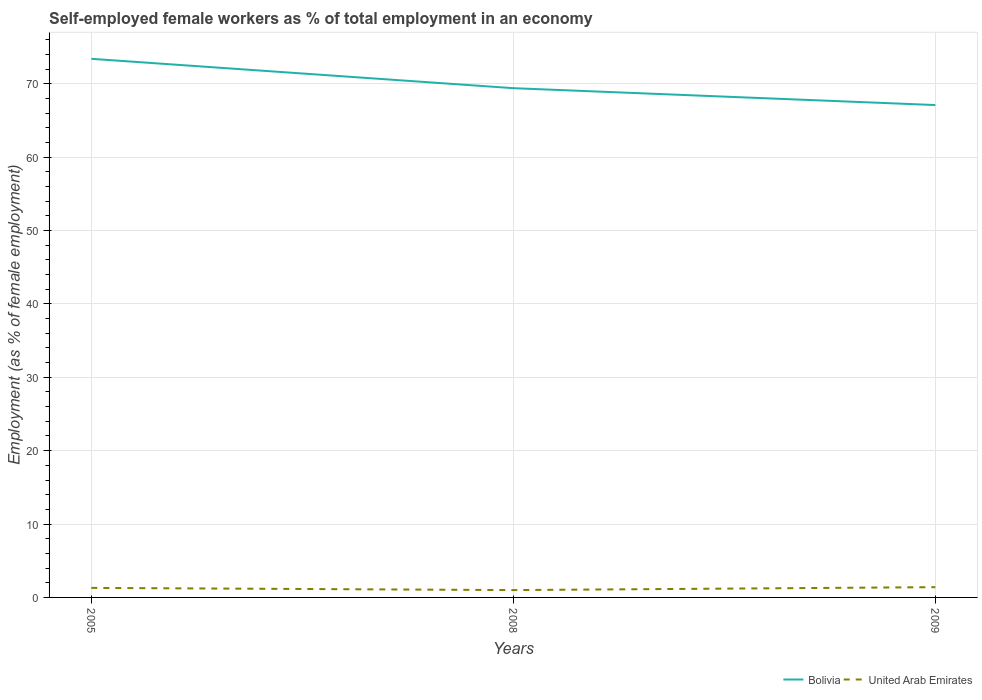Is the number of lines equal to the number of legend labels?
Offer a very short reply. Yes. Across all years, what is the maximum percentage of self-employed female workers in United Arab Emirates?
Offer a terse response. 1. In which year was the percentage of self-employed female workers in Bolivia maximum?
Your response must be concise. 2009. What is the total percentage of self-employed female workers in United Arab Emirates in the graph?
Keep it short and to the point. -0.4. What is the difference between the highest and the second highest percentage of self-employed female workers in United Arab Emirates?
Make the answer very short. 0.4. What is the difference between the highest and the lowest percentage of self-employed female workers in United Arab Emirates?
Offer a terse response. 2. How many years are there in the graph?
Offer a very short reply. 3. What is the difference between two consecutive major ticks on the Y-axis?
Make the answer very short. 10. Does the graph contain any zero values?
Offer a terse response. No. Does the graph contain grids?
Offer a very short reply. Yes. Where does the legend appear in the graph?
Your answer should be compact. Bottom right. How many legend labels are there?
Provide a succinct answer. 2. How are the legend labels stacked?
Your answer should be compact. Horizontal. What is the title of the graph?
Keep it short and to the point. Self-employed female workers as % of total employment in an economy. Does "Poland" appear as one of the legend labels in the graph?
Provide a succinct answer. No. What is the label or title of the Y-axis?
Your response must be concise. Employment (as % of female employment). What is the Employment (as % of female employment) in Bolivia in 2005?
Offer a terse response. 73.4. What is the Employment (as % of female employment) of United Arab Emirates in 2005?
Your answer should be compact. 1.3. What is the Employment (as % of female employment) of Bolivia in 2008?
Offer a very short reply. 69.4. What is the Employment (as % of female employment) of Bolivia in 2009?
Keep it short and to the point. 67.1. What is the Employment (as % of female employment) of United Arab Emirates in 2009?
Offer a terse response. 1.4. Across all years, what is the maximum Employment (as % of female employment) of Bolivia?
Keep it short and to the point. 73.4. Across all years, what is the maximum Employment (as % of female employment) in United Arab Emirates?
Your response must be concise. 1.4. Across all years, what is the minimum Employment (as % of female employment) of Bolivia?
Ensure brevity in your answer.  67.1. Across all years, what is the minimum Employment (as % of female employment) in United Arab Emirates?
Your response must be concise. 1. What is the total Employment (as % of female employment) in Bolivia in the graph?
Your answer should be very brief. 209.9. What is the difference between the Employment (as % of female employment) of Bolivia in 2005 and that in 2008?
Your answer should be compact. 4. What is the difference between the Employment (as % of female employment) in United Arab Emirates in 2005 and that in 2008?
Make the answer very short. 0.3. What is the difference between the Employment (as % of female employment) of Bolivia in 2005 and that in 2009?
Offer a terse response. 6.3. What is the difference between the Employment (as % of female employment) of United Arab Emirates in 2008 and that in 2009?
Offer a very short reply. -0.4. What is the difference between the Employment (as % of female employment) in Bolivia in 2005 and the Employment (as % of female employment) in United Arab Emirates in 2008?
Keep it short and to the point. 72.4. What is the average Employment (as % of female employment) in Bolivia per year?
Offer a very short reply. 69.97. What is the average Employment (as % of female employment) of United Arab Emirates per year?
Provide a succinct answer. 1.23. In the year 2005, what is the difference between the Employment (as % of female employment) of Bolivia and Employment (as % of female employment) of United Arab Emirates?
Offer a terse response. 72.1. In the year 2008, what is the difference between the Employment (as % of female employment) in Bolivia and Employment (as % of female employment) in United Arab Emirates?
Keep it short and to the point. 68.4. In the year 2009, what is the difference between the Employment (as % of female employment) of Bolivia and Employment (as % of female employment) of United Arab Emirates?
Offer a terse response. 65.7. What is the ratio of the Employment (as % of female employment) of Bolivia in 2005 to that in 2008?
Your answer should be compact. 1.06. What is the ratio of the Employment (as % of female employment) in United Arab Emirates in 2005 to that in 2008?
Ensure brevity in your answer.  1.3. What is the ratio of the Employment (as % of female employment) of Bolivia in 2005 to that in 2009?
Offer a terse response. 1.09. What is the ratio of the Employment (as % of female employment) in Bolivia in 2008 to that in 2009?
Give a very brief answer. 1.03. What is the difference between the highest and the second highest Employment (as % of female employment) of Bolivia?
Keep it short and to the point. 4. What is the difference between the highest and the lowest Employment (as % of female employment) in Bolivia?
Keep it short and to the point. 6.3. 